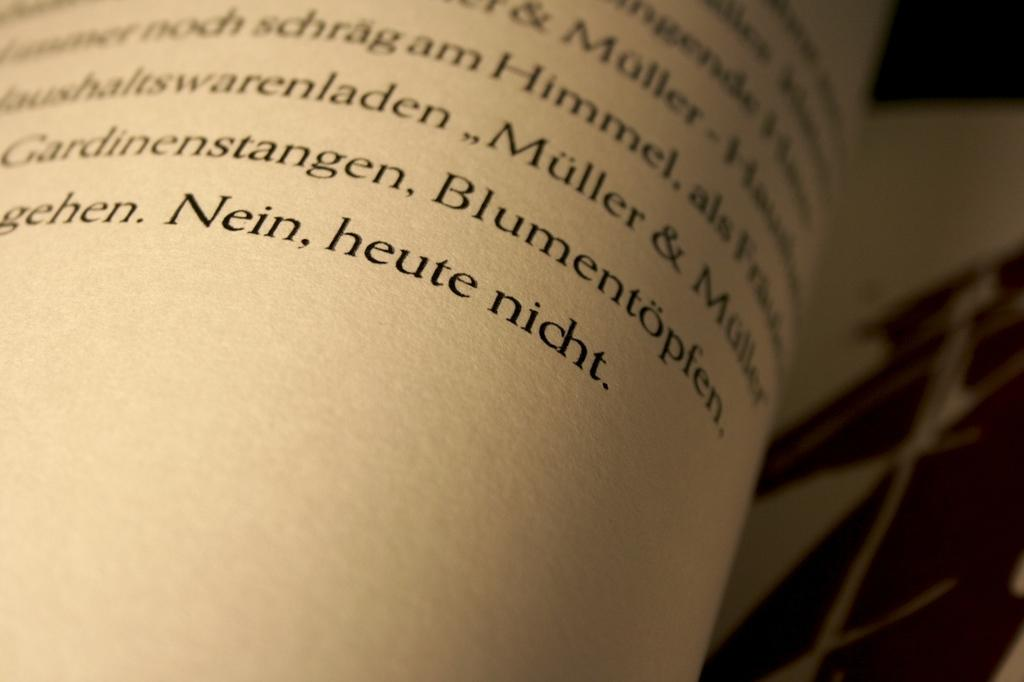What is the primary object in the image? There is a paper with text in the image. Can you describe the background of the image? The background of the image is blurry. What type of chalk is being used to write the text on the paper? There is no chalk present in the image; the text is written on the paper, not on a chalkboard or similar surface. 